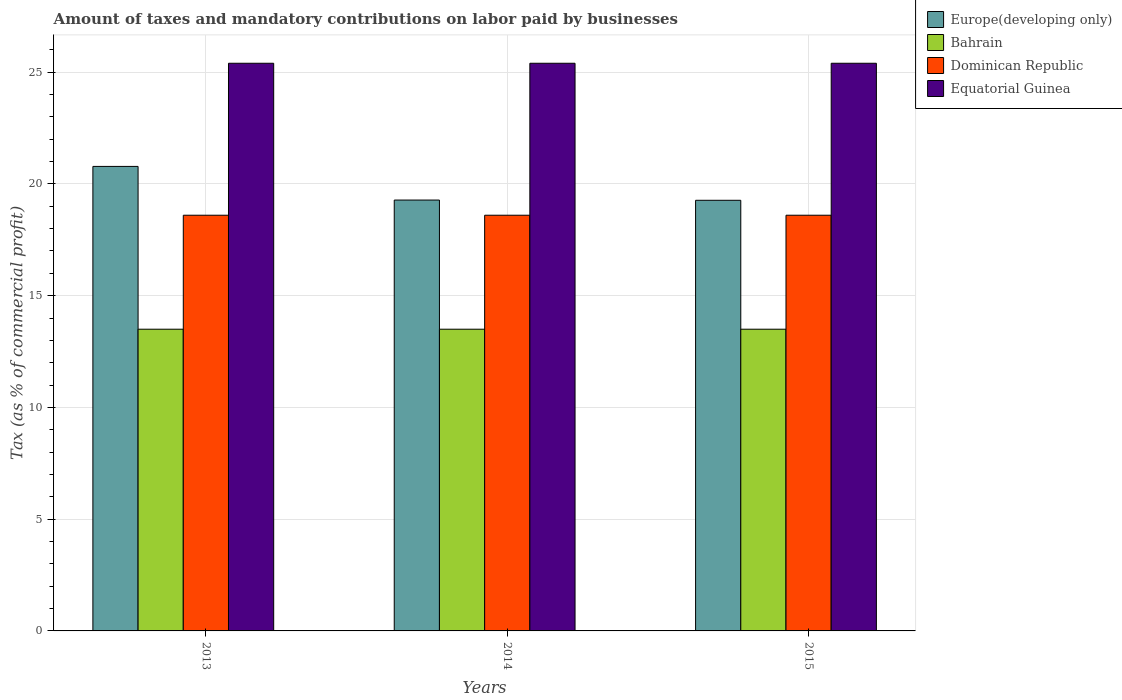How many groups of bars are there?
Your answer should be compact. 3. Are the number of bars per tick equal to the number of legend labels?
Ensure brevity in your answer.  Yes. How many bars are there on the 2nd tick from the right?
Provide a short and direct response. 4. What is the label of the 3rd group of bars from the left?
Give a very brief answer. 2015. In how many cases, is the number of bars for a given year not equal to the number of legend labels?
Your answer should be very brief. 0. What is the percentage of taxes paid by businesses in Equatorial Guinea in 2014?
Provide a succinct answer. 25.4. Across all years, what is the maximum percentage of taxes paid by businesses in Europe(developing only)?
Provide a succinct answer. 20.78. Across all years, what is the minimum percentage of taxes paid by businesses in Europe(developing only)?
Provide a succinct answer. 19.27. In which year was the percentage of taxes paid by businesses in Equatorial Guinea maximum?
Provide a succinct answer. 2013. In which year was the percentage of taxes paid by businesses in Bahrain minimum?
Your answer should be very brief. 2013. What is the total percentage of taxes paid by businesses in Dominican Republic in the graph?
Keep it short and to the point. 55.8. What is the difference between the percentage of taxes paid by businesses in Europe(developing only) in 2014 and the percentage of taxes paid by businesses in Equatorial Guinea in 2013?
Keep it short and to the point. -6.12. What is the average percentage of taxes paid by businesses in Equatorial Guinea per year?
Keep it short and to the point. 25.4. In the year 2014, what is the difference between the percentage of taxes paid by businesses in Europe(developing only) and percentage of taxes paid by businesses in Dominican Republic?
Offer a very short reply. 0.68. In how many years, is the percentage of taxes paid by businesses in Dominican Republic greater than 23 %?
Provide a succinct answer. 0. What is the ratio of the percentage of taxes paid by businesses in Bahrain in 2013 to that in 2015?
Your answer should be compact. 1. Is the percentage of taxes paid by businesses in Europe(developing only) in 2014 less than that in 2015?
Ensure brevity in your answer.  No. Is the difference between the percentage of taxes paid by businesses in Europe(developing only) in 2013 and 2014 greater than the difference between the percentage of taxes paid by businesses in Dominican Republic in 2013 and 2014?
Provide a succinct answer. Yes. What is the difference between the highest and the second highest percentage of taxes paid by businesses in Equatorial Guinea?
Provide a succinct answer. 0. In how many years, is the percentage of taxes paid by businesses in Bahrain greater than the average percentage of taxes paid by businesses in Bahrain taken over all years?
Offer a terse response. 0. Is the sum of the percentage of taxes paid by businesses in Bahrain in 2014 and 2015 greater than the maximum percentage of taxes paid by businesses in Equatorial Guinea across all years?
Offer a very short reply. Yes. Is it the case that in every year, the sum of the percentage of taxes paid by businesses in Dominican Republic and percentage of taxes paid by businesses in Europe(developing only) is greater than the sum of percentage of taxes paid by businesses in Equatorial Guinea and percentage of taxes paid by businesses in Bahrain?
Your response must be concise. Yes. What does the 2nd bar from the left in 2013 represents?
Offer a very short reply. Bahrain. What does the 2nd bar from the right in 2015 represents?
Offer a very short reply. Dominican Republic. Is it the case that in every year, the sum of the percentage of taxes paid by businesses in Equatorial Guinea and percentage of taxes paid by businesses in Dominican Republic is greater than the percentage of taxes paid by businesses in Europe(developing only)?
Provide a succinct answer. Yes. How many bars are there?
Your answer should be very brief. 12. Are all the bars in the graph horizontal?
Keep it short and to the point. No. How many years are there in the graph?
Ensure brevity in your answer.  3. What is the difference between two consecutive major ticks on the Y-axis?
Offer a very short reply. 5. Does the graph contain any zero values?
Give a very brief answer. No. How many legend labels are there?
Provide a succinct answer. 4. How are the legend labels stacked?
Your answer should be compact. Vertical. What is the title of the graph?
Your answer should be compact. Amount of taxes and mandatory contributions on labor paid by businesses. Does "Turkmenistan" appear as one of the legend labels in the graph?
Offer a very short reply. No. What is the label or title of the Y-axis?
Your answer should be very brief. Tax (as % of commercial profit). What is the Tax (as % of commercial profit) in Europe(developing only) in 2013?
Offer a very short reply. 20.78. What is the Tax (as % of commercial profit) of Dominican Republic in 2013?
Offer a very short reply. 18.6. What is the Tax (as % of commercial profit) in Equatorial Guinea in 2013?
Your response must be concise. 25.4. What is the Tax (as % of commercial profit) of Europe(developing only) in 2014?
Make the answer very short. 19.28. What is the Tax (as % of commercial profit) in Dominican Republic in 2014?
Provide a succinct answer. 18.6. What is the Tax (as % of commercial profit) of Equatorial Guinea in 2014?
Provide a short and direct response. 25.4. What is the Tax (as % of commercial profit) of Europe(developing only) in 2015?
Your answer should be very brief. 19.27. What is the Tax (as % of commercial profit) of Bahrain in 2015?
Your answer should be very brief. 13.5. What is the Tax (as % of commercial profit) in Dominican Republic in 2015?
Give a very brief answer. 18.6. What is the Tax (as % of commercial profit) of Equatorial Guinea in 2015?
Offer a terse response. 25.4. Across all years, what is the maximum Tax (as % of commercial profit) in Europe(developing only)?
Provide a succinct answer. 20.78. Across all years, what is the maximum Tax (as % of commercial profit) in Bahrain?
Provide a succinct answer. 13.5. Across all years, what is the maximum Tax (as % of commercial profit) of Equatorial Guinea?
Your response must be concise. 25.4. Across all years, what is the minimum Tax (as % of commercial profit) of Europe(developing only)?
Your answer should be very brief. 19.27. Across all years, what is the minimum Tax (as % of commercial profit) of Bahrain?
Your answer should be very brief. 13.5. Across all years, what is the minimum Tax (as % of commercial profit) in Dominican Republic?
Your answer should be very brief. 18.6. Across all years, what is the minimum Tax (as % of commercial profit) of Equatorial Guinea?
Give a very brief answer. 25.4. What is the total Tax (as % of commercial profit) in Europe(developing only) in the graph?
Ensure brevity in your answer.  59.33. What is the total Tax (as % of commercial profit) of Bahrain in the graph?
Make the answer very short. 40.5. What is the total Tax (as % of commercial profit) of Dominican Republic in the graph?
Provide a short and direct response. 55.8. What is the total Tax (as % of commercial profit) of Equatorial Guinea in the graph?
Provide a succinct answer. 76.2. What is the difference between the Tax (as % of commercial profit) in Europe(developing only) in 2013 and that in 2014?
Offer a terse response. 1.51. What is the difference between the Tax (as % of commercial profit) of Equatorial Guinea in 2013 and that in 2014?
Your answer should be compact. 0. What is the difference between the Tax (as % of commercial profit) of Europe(developing only) in 2013 and that in 2015?
Your answer should be very brief. 1.52. What is the difference between the Tax (as % of commercial profit) in Europe(developing only) in 2014 and that in 2015?
Your answer should be very brief. 0.01. What is the difference between the Tax (as % of commercial profit) of Dominican Republic in 2014 and that in 2015?
Give a very brief answer. 0. What is the difference between the Tax (as % of commercial profit) in Equatorial Guinea in 2014 and that in 2015?
Your answer should be very brief. 0. What is the difference between the Tax (as % of commercial profit) of Europe(developing only) in 2013 and the Tax (as % of commercial profit) of Bahrain in 2014?
Keep it short and to the point. 7.28. What is the difference between the Tax (as % of commercial profit) in Europe(developing only) in 2013 and the Tax (as % of commercial profit) in Dominican Republic in 2014?
Ensure brevity in your answer.  2.18. What is the difference between the Tax (as % of commercial profit) in Europe(developing only) in 2013 and the Tax (as % of commercial profit) in Equatorial Guinea in 2014?
Provide a short and direct response. -4.62. What is the difference between the Tax (as % of commercial profit) of Dominican Republic in 2013 and the Tax (as % of commercial profit) of Equatorial Guinea in 2014?
Offer a terse response. -6.8. What is the difference between the Tax (as % of commercial profit) of Europe(developing only) in 2013 and the Tax (as % of commercial profit) of Bahrain in 2015?
Make the answer very short. 7.28. What is the difference between the Tax (as % of commercial profit) of Europe(developing only) in 2013 and the Tax (as % of commercial profit) of Dominican Republic in 2015?
Your answer should be compact. 2.18. What is the difference between the Tax (as % of commercial profit) of Europe(developing only) in 2013 and the Tax (as % of commercial profit) of Equatorial Guinea in 2015?
Offer a terse response. -4.62. What is the difference between the Tax (as % of commercial profit) of Dominican Republic in 2013 and the Tax (as % of commercial profit) of Equatorial Guinea in 2015?
Your response must be concise. -6.8. What is the difference between the Tax (as % of commercial profit) in Europe(developing only) in 2014 and the Tax (as % of commercial profit) in Bahrain in 2015?
Keep it short and to the point. 5.78. What is the difference between the Tax (as % of commercial profit) of Europe(developing only) in 2014 and the Tax (as % of commercial profit) of Dominican Republic in 2015?
Your answer should be compact. 0.68. What is the difference between the Tax (as % of commercial profit) of Europe(developing only) in 2014 and the Tax (as % of commercial profit) of Equatorial Guinea in 2015?
Make the answer very short. -6.12. What is the difference between the Tax (as % of commercial profit) of Bahrain in 2014 and the Tax (as % of commercial profit) of Equatorial Guinea in 2015?
Provide a succinct answer. -11.9. What is the average Tax (as % of commercial profit) in Europe(developing only) per year?
Keep it short and to the point. 19.78. What is the average Tax (as % of commercial profit) in Dominican Republic per year?
Keep it short and to the point. 18.6. What is the average Tax (as % of commercial profit) in Equatorial Guinea per year?
Provide a short and direct response. 25.4. In the year 2013, what is the difference between the Tax (as % of commercial profit) of Europe(developing only) and Tax (as % of commercial profit) of Bahrain?
Your answer should be very brief. 7.28. In the year 2013, what is the difference between the Tax (as % of commercial profit) of Europe(developing only) and Tax (as % of commercial profit) of Dominican Republic?
Offer a terse response. 2.18. In the year 2013, what is the difference between the Tax (as % of commercial profit) in Europe(developing only) and Tax (as % of commercial profit) in Equatorial Guinea?
Make the answer very short. -4.62. In the year 2013, what is the difference between the Tax (as % of commercial profit) in Bahrain and Tax (as % of commercial profit) in Dominican Republic?
Provide a succinct answer. -5.1. In the year 2014, what is the difference between the Tax (as % of commercial profit) of Europe(developing only) and Tax (as % of commercial profit) of Bahrain?
Your answer should be very brief. 5.78. In the year 2014, what is the difference between the Tax (as % of commercial profit) in Europe(developing only) and Tax (as % of commercial profit) in Dominican Republic?
Give a very brief answer. 0.68. In the year 2014, what is the difference between the Tax (as % of commercial profit) in Europe(developing only) and Tax (as % of commercial profit) in Equatorial Guinea?
Make the answer very short. -6.12. In the year 2014, what is the difference between the Tax (as % of commercial profit) in Bahrain and Tax (as % of commercial profit) in Equatorial Guinea?
Keep it short and to the point. -11.9. In the year 2015, what is the difference between the Tax (as % of commercial profit) in Europe(developing only) and Tax (as % of commercial profit) in Bahrain?
Offer a very short reply. 5.77. In the year 2015, what is the difference between the Tax (as % of commercial profit) in Europe(developing only) and Tax (as % of commercial profit) in Dominican Republic?
Make the answer very short. 0.67. In the year 2015, what is the difference between the Tax (as % of commercial profit) of Europe(developing only) and Tax (as % of commercial profit) of Equatorial Guinea?
Offer a terse response. -6.13. In the year 2015, what is the difference between the Tax (as % of commercial profit) in Bahrain and Tax (as % of commercial profit) in Dominican Republic?
Offer a terse response. -5.1. In the year 2015, what is the difference between the Tax (as % of commercial profit) in Bahrain and Tax (as % of commercial profit) in Equatorial Guinea?
Keep it short and to the point. -11.9. In the year 2015, what is the difference between the Tax (as % of commercial profit) of Dominican Republic and Tax (as % of commercial profit) of Equatorial Guinea?
Your answer should be compact. -6.8. What is the ratio of the Tax (as % of commercial profit) in Europe(developing only) in 2013 to that in 2014?
Make the answer very short. 1.08. What is the ratio of the Tax (as % of commercial profit) in Bahrain in 2013 to that in 2014?
Keep it short and to the point. 1. What is the ratio of the Tax (as % of commercial profit) of Europe(developing only) in 2013 to that in 2015?
Your response must be concise. 1.08. What is the ratio of the Tax (as % of commercial profit) in Bahrain in 2013 to that in 2015?
Your answer should be compact. 1. What is the ratio of the Tax (as % of commercial profit) of Bahrain in 2014 to that in 2015?
Offer a terse response. 1. What is the difference between the highest and the second highest Tax (as % of commercial profit) of Europe(developing only)?
Your response must be concise. 1.51. What is the difference between the highest and the second highest Tax (as % of commercial profit) in Bahrain?
Offer a terse response. 0. What is the difference between the highest and the second highest Tax (as % of commercial profit) in Equatorial Guinea?
Offer a very short reply. 0. What is the difference between the highest and the lowest Tax (as % of commercial profit) in Europe(developing only)?
Ensure brevity in your answer.  1.52. What is the difference between the highest and the lowest Tax (as % of commercial profit) in Bahrain?
Make the answer very short. 0. What is the difference between the highest and the lowest Tax (as % of commercial profit) in Dominican Republic?
Your answer should be compact. 0. What is the difference between the highest and the lowest Tax (as % of commercial profit) in Equatorial Guinea?
Make the answer very short. 0. 